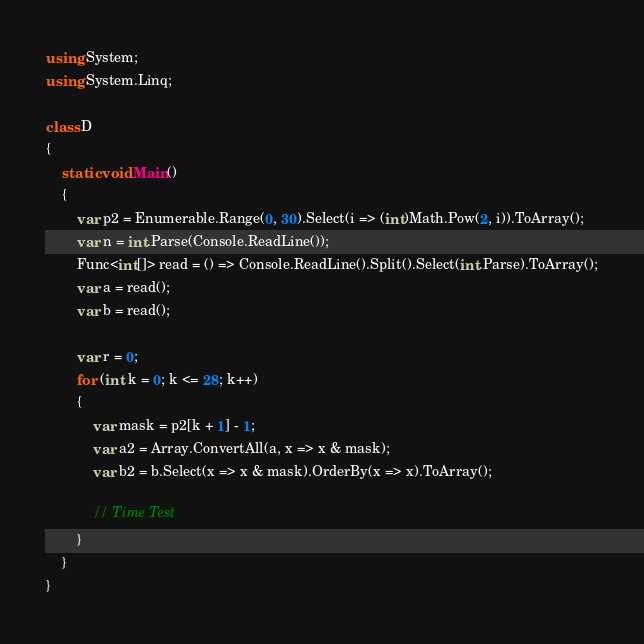Convert code to text. <code><loc_0><loc_0><loc_500><loc_500><_C#_>using System;
using System.Linq;

class D
{
	static void Main()
	{
		var p2 = Enumerable.Range(0, 30).Select(i => (int)Math.Pow(2, i)).ToArray();
		var n = int.Parse(Console.ReadLine());
		Func<int[]> read = () => Console.ReadLine().Split().Select(int.Parse).ToArray();
		var a = read();
		var b = read();

		var r = 0;
		for (int k = 0; k <= 28; k++)
		{
			var mask = p2[k + 1] - 1;
			var a2 = Array.ConvertAll(a, x => x & mask);
			var b2 = b.Select(x => x & mask).OrderBy(x => x).ToArray();

			// Time Test
		}
	}
}
</code> 